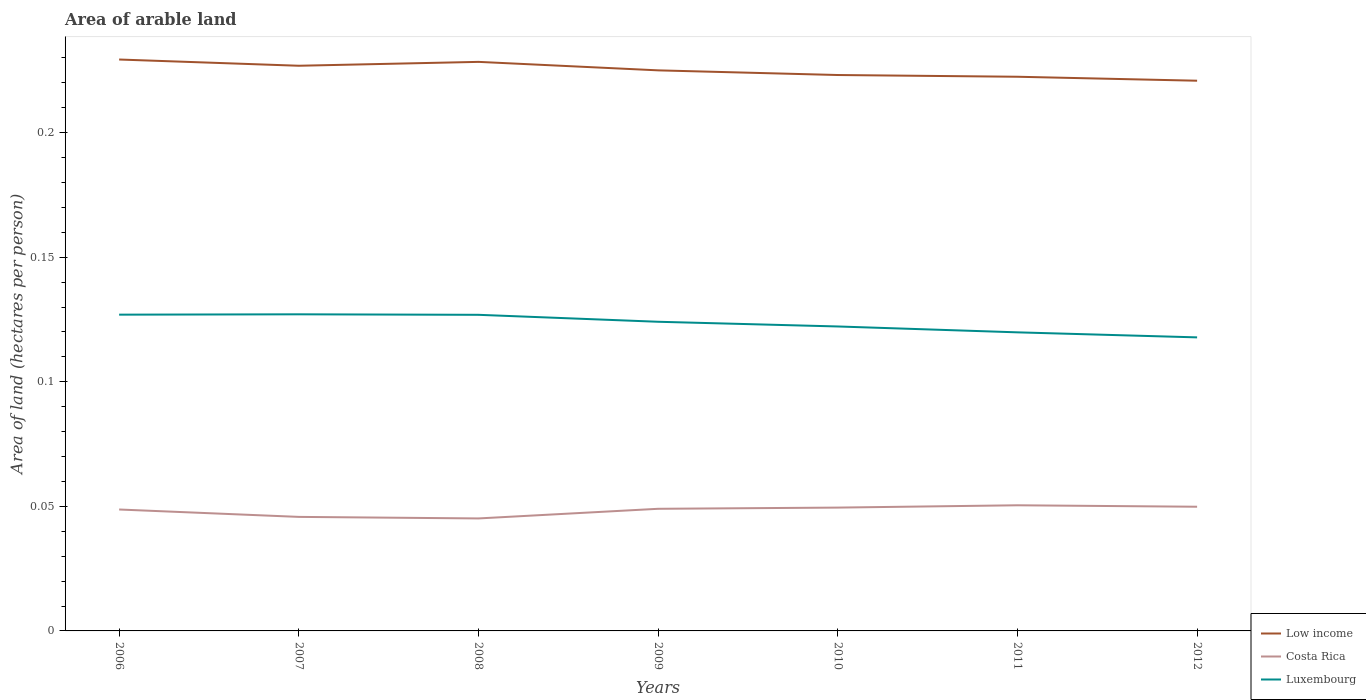Does the line corresponding to Costa Rica intersect with the line corresponding to Low income?
Ensure brevity in your answer.  No. Is the number of lines equal to the number of legend labels?
Keep it short and to the point. Yes. Across all years, what is the maximum total arable land in Luxembourg?
Give a very brief answer. 0.12. What is the total total arable land in Low income in the graph?
Offer a terse response. 0. What is the difference between the highest and the second highest total arable land in Costa Rica?
Your answer should be compact. 0.01. Is the total arable land in Low income strictly greater than the total arable land in Luxembourg over the years?
Your answer should be very brief. No. How many lines are there?
Provide a short and direct response. 3. What is the difference between two consecutive major ticks on the Y-axis?
Give a very brief answer. 0.05. Does the graph contain grids?
Give a very brief answer. No. What is the title of the graph?
Your response must be concise. Area of arable land. Does "Eritrea" appear as one of the legend labels in the graph?
Offer a very short reply. No. What is the label or title of the X-axis?
Keep it short and to the point. Years. What is the label or title of the Y-axis?
Make the answer very short. Area of land (hectares per person). What is the Area of land (hectares per person) of Low income in 2006?
Make the answer very short. 0.23. What is the Area of land (hectares per person) in Costa Rica in 2006?
Offer a very short reply. 0.05. What is the Area of land (hectares per person) in Luxembourg in 2006?
Provide a short and direct response. 0.13. What is the Area of land (hectares per person) in Low income in 2007?
Offer a very short reply. 0.23. What is the Area of land (hectares per person) of Costa Rica in 2007?
Offer a very short reply. 0.05. What is the Area of land (hectares per person) of Luxembourg in 2007?
Provide a succinct answer. 0.13. What is the Area of land (hectares per person) of Low income in 2008?
Give a very brief answer. 0.23. What is the Area of land (hectares per person) in Costa Rica in 2008?
Provide a succinct answer. 0.05. What is the Area of land (hectares per person) of Luxembourg in 2008?
Offer a very short reply. 0.13. What is the Area of land (hectares per person) in Low income in 2009?
Offer a very short reply. 0.23. What is the Area of land (hectares per person) in Costa Rica in 2009?
Provide a succinct answer. 0.05. What is the Area of land (hectares per person) of Luxembourg in 2009?
Give a very brief answer. 0.12. What is the Area of land (hectares per person) in Low income in 2010?
Provide a succinct answer. 0.22. What is the Area of land (hectares per person) of Costa Rica in 2010?
Your response must be concise. 0.05. What is the Area of land (hectares per person) of Luxembourg in 2010?
Provide a succinct answer. 0.12. What is the Area of land (hectares per person) in Low income in 2011?
Provide a succinct answer. 0.22. What is the Area of land (hectares per person) of Costa Rica in 2011?
Provide a short and direct response. 0.05. What is the Area of land (hectares per person) of Luxembourg in 2011?
Give a very brief answer. 0.12. What is the Area of land (hectares per person) in Low income in 2012?
Your response must be concise. 0.22. What is the Area of land (hectares per person) in Costa Rica in 2012?
Keep it short and to the point. 0.05. What is the Area of land (hectares per person) in Luxembourg in 2012?
Your response must be concise. 0.12. Across all years, what is the maximum Area of land (hectares per person) in Low income?
Offer a terse response. 0.23. Across all years, what is the maximum Area of land (hectares per person) of Costa Rica?
Your answer should be very brief. 0.05. Across all years, what is the maximum Area of land (hectares per person) of Luxembourg?
Offer a very short reply. 0.13. Across all years, what is the minimum Area of land (hectares per person) in Low income?
Ensure brevity in your answer.  0.22. Across all years, what is the minimum Area of land (hectares per person) of Costa Rica?
Give a very brief answer. 0.05. Across all years, what is the minimum Area of land (hectares per person) in Luxembourg?
Offer a terse response. 0.12. What is the total Area of land (hectares per person) in Low income in the graph?
Your response must be concise. 1.58. What is the total Area of land (hectares per person) in Costa Rica in the graph?
Your answer should be compact. 0.34. What is the total Area of land (hectares per person) in Luxembourg in the graph?
Make the answer very short. 0.86. What is the difference between the Area of land (hectares per person) in Low income in 2006 and that in 2007?
Your response must be concise. 0. What is the difference between the Area of land (hectares per person) of Costa Rica in 2006 and that in 2007?
Provide a succinct answer. 0. What is the difference between the Area of land (hectares per person) of Luxembourg in 2006 and that in 2007?
Offer a very short reply. -0. What is the difference between the Area of land (hectares per person) in Low income in 2006 and that in 2008?
Your response must be concise. 0. What is the difference between the Area of land (hectares per person) of Costa Rica in 2006 and that in 2008?
Ensure brevity in your answer.  0. What is the difference between the Area of land (hectares per person) in Luxembourg in 2006 and that in 2008?
Provide a short and direct response. 0. What is the difference between the Area of land (hectares per person) of Low income in 2006 and that in 2009?
Ensure brevity in your answer.  0. What is the difference between the Area of land (hectares per person) of Costa Rica in 2006 and that in 2009?
Keep it short and to the point. -0. What is the difference between the Area of land (hectares per person) in Luxembourg in 2006 and that in 2009?
Your answer should be compact. 0. What is the difference between the Area of land (hectares per person) in Low income in 2006 and that in 2010?
Give a very brief answer. 0.01. What is the difference between the Area of land (hectares per person) of Costa Rica in 2006 and that in 2010?
Offer a terse response. -0. What is the difference between the Area of land (hectares per person) of Luxembourg in 2006 and that in 2010?
Offer a terse response. 0. What is the difference between the Area of land (hectares per person) of Low income in 2006 and that in 2011?
Offer a terse response. 0.01. What is the difference between the Area of land (hectares per person) in Costa Rica in 2006 and that in 2011?
Ensure brevity in your answer.  -0. What is the difference between the Area of land (hectares per person) of Luxembourg in 2006 and that in 2011?
Ensure brevity in your answer.  0.01. What is the difference between the Area of land (hectares per person) in Low income in 2006 and that in 2012?
Offer a very short reply. 0.01. What is the difference between the Area of land (hectares per person) in Costa Rica in 2006 and that in 2012?
Offer a very short reply. -0. What is the difference between the Area of land (hectares per person) of Luxembourg in 2006 and that in 2012?
Your response must be concise. 0.01. What is the difference between the Area of land (hectares per person) of Low income in 2007 and that in 2008?
Make the answer very short. -0. What is the difference between the Area of land (hectares per person) of Costa Rica in 2007 and that in 2008?
Your answer should be very brief. 0. What is the difference between the Area of land (hectares per person) of Luxembourg in 2007 and that in 2008?
Your answer should be very brief. 0. What is the difference between the Area of land (hectares per person) in Low income in 2007 and that in 2009?
Provide a short and direct response. 0. What is the difference between the Area of land (hectares per person) in Costa Rica in 2007 and that in 2009?
Provide a short and direct response. -0. What is the difference between the Area of land (hectares per person) in Luxembourg in 2007 and that in 2009?
Give a very brief answer. 0. What is the difference between the Area of land (hectares per person) in Low income in 2007 and that in 2010?
Your response must be concise. 0. What is the difference between the Area of land (hectares per person) of Costa Rica in 2007 and that in 2010?
Ensure brevity in your answer.  -0. What is the difference between the Area of land (hectares per person) in Luxembourg in 2007 and that in 2010?
Offer a terse response. 0. What is the difference between the Area of land (hectares per person) of Low income in 2007 and that in 2011?
Make the answer very short. 0. What is the difference between the Area of land (hectares per person) in Costa Rica in 2007 and that in 2011?
Provide a succinct answer. -0. What is the difference between the Area of land (hectares per person) in Luxembourg in 2007 and that in 2011?
Ensure brevity in your answer.  0.01. What is the difference between the Area of land (hectares per person) of Low income in 2007 and that in 2012?
Offer a very short reply. 0.01. What is the difference between the Area of land (hectares per person) in Costa Rica in 2007 and that in 2012?
Ensure brevity in your answer.  -0. What is the difference between the Area of land (hectares per person) of Luxembourg in 2007 and that in 2012?
Provide a succinct answer. 0.01. What is the difference between the Area of land (hectares per person) in Low income in 2008 and that in 2009?
Give a very brief answer. 0. What is the difference between the Area of land (hectares per person) in Costa Rica in 2008 and that in 2009?
Keep it short and to the point. -0. What is the difference between the Area of land (hectares per person) of Luxembourg in 2008 and that in 2009?
Provide a succinct answer. 0. What is the difference between the Area of land (hectares per person) of Low income in 2008 and that in 2010?
Your answer should be compact. 0.01. What is the difference between the Area of land (hectares per person) of Costa Rica in 2008 and that in 2010?
Give a very brief answer. -0. What is the difference between the Area of land (hectares per person) in Luxembourg in 2008 and that in 2010?
Your answer should be very brief. 0. What is the difference between the Area of land (hectares per person) in Low income in 2008 and that in 2011?
Give a very brief answer. 0.01. What is the difference between the Area of land (hectares per person) of Costa Rica in 2008 and that in 2011?
Ensure brevity in your answer.  -0.01. What is the difference between the Area of land (hectares per person) of Luxembourg in 2008 and that in 2011?
Ensure brevity in your answer.  0.01. What is the difference between the Area of land (hectares per person) of Low income in 2008 and that in 2012?
Your answer should be compact. 0.01. What is the difference between the Area of land (hectares per person) in Costa Rica in 2008 and that in 2012?
Your answer should be very brief. -0. What is the difference between the Area of land (hectares per person) of Luxembourg in 2008 and that in 2012?
Offer a terse response. 0.01. What is the difference between the Area of land (hectares per person) of Low income in 2009 and that in 2010?
Ensure brevity in your answer.  0. What is the difference between the Area of land (hectares per person) of Costa Rica in 2009 and that in 2010?
Provide a short and direct response. -0. What is the difference between the Area of land (hectares per person) in Luxembourg in 2009 and that in 2010?
Your answer should be compact. 0. What is the difference between the Area of land (hectares per person) in Low income in 2009 and that in 2011?
Give a very brief answer. 0. What is the difference between the Area of land (hectares per person) in Costa Rica in 2009 and that in 2011?
Make the answer very short. -0. What is the difference between the Area of land (hectares per person) in Luxembourg in 2009 and that in 2011?
Provide a succinct answer. 0. What is the difference between the Area of land (hectares per person) in Low income in 2009 and that in 2012?
Ensure brevity in your answer.  0. What is the difference between the Area of land (hectares per person) of Costa Rica in 2009 and that in 2012?
Provide a succinct answer. -0. What is the difference between the Area of land (hectares per person) of Luxembourg in 2009 and that in 2012?
Provide a succinct answer. 0.01. What is the difference between the Area of land (hectares per person) of Low income in 2010 and that in 2011?
Give a very brief answer. 0. What is the difference between the Area of land (hectares per person) in Costa Rica in 2010 and that in 2011?
Provide a short and direct response. -0. What is the difference between the Area of land (hectares per person) in Luxembourg in 2010 and that in 2011?
Provide a succinct answer. 0. What is the difference between the Area of land (hectares per person) of Low income in 2010 and that in 2012?
Your response must be concise. 0. What is the difference between the Area of land (hectares per person) of Costa Rica in 2010 and that in 2012?
Offer a terse response. -0. What is the difference between the Area of land (hectares per person) of Luxembourg in 2010 and that in 2012?
Give a very brief answer. 0. What is the difference between the Area of land (hectares per person) of Low income in 2011 and that in 2012?
Offer a very short reply. 0. What is the difference between the Area of land (hectares per person) in Costa Rica in 2011 and that in 2012?
Provide a short and direct response. 0. What is the difference between the Area of land (hectares per person) of Luxembourg in 2011 and that in 2012?
Provide a succinct answer. 0. What is the difference between the Area of land (hectares per person) in Low income in 2006 and the Area of land (hectares per person) in Costa Rica in 2007?
Keep it short and to the point. 0.18. What is the difference between the Area of land (hectares per person) in Low income in 2006 and the Area of land (hectares per person) in Luxembourg in 2007?
Offer a very short reply. 0.1. What is the difference between the Area of land (hectares per person) in Costa Rica in 2006 and the Area of land (hectares per person) in Luxembourg in 2007?
Your answer should be very brief. -0.08. What is the difference between the Area of land (hectares per person) of Low income in 2006 and the Area of land (hectares per person) of Costa Rica in 2008?
Your response must be concise. 0.18. What is the difference between the Area of land (hectares per person) in Low income in 2006 and the Area of land (hectares per person) in Luxembourg in 2008?
Give a very brief answer. 0.1. What is the difference between the Area of land (hectares per person) of Costa Rica in 2006 and the Area of land (hectares per person) of Luxembourg in 2008?
Make the answer very short. -0.08. What is the difference between the Area of land (hectares per person) of Low income in 2006 and the Area of land (hectares per person) of Costa Rica in 2009?
Provide a succinct answer. 0.18. What is the difference between the Area of land (hectares per person) in Low income in 2006 and the Area of land (hectares per person) in Luxembourg in 2009?
Provide a succinct answer. 0.11. What is the difference between the Area of land (hectares per person) in Costa Rica in 2006 and the Area of land (hectares per person) in Luxembourg in 2009?
Your answer should be very brief. -0.08. What is the difference between the Area of land (hectares per person) in Low income in 2006 and the Area of land (hectares per person) in Costa Rica in 2010?
Give a very brief answer. 0.18. What is the difference between the Area of land (hectares per person) of Low income in 2006 and the Area of land (hectares per person) of Luxembourg in 2010?
Give a very brief answer. 0.11. What is the difference between the Area of land (hectares per person) in Costa Rica in 2006 and the Area of land (hectares per person) in Luxembourg in 2010?
Ensure brevity in your answer.  -0.07. What is the difference between the Area of land (hectares per person) of Low income in 2006 and the Area of land (hectares per person) of Costa Rica in 2011?
Keep it short and to the point. 0.18. What is the difference between the Area of land (hectares per person) in Low income in 2006 and the Area of land (hectares per person) in Luxembourg in 2011?
Your answer should be very brief. 0.11. What is the difference between the Area of land (hectares per person) of Costa Rica in 2006 and the Area of land (hectares per person) of Luxembourg in 2011?
Give a very brief answer. -0.07. What is the difference between the Area of land (hectares per person) of Low income in 2006 and the Area of land (hectares per person) of Costa Rica in 2012?
Your answer should be very brief. 0.18. What is the difference between the Area of land (hectares per person) in Low income in 2006 and the Area of land (hectares per person) in Luxembourg in 2012?
Offer a very short reply. 0.11. What is the difference between the Area of land (hectares per person) of Costa Rica in 2006 and the Area of land (hectares per person) of Luxembourg in 2012?
Provide a short and direct response. -0.07. What is the difference between the Area of land (hectares per person) in Low income in 2007 and the Area of land (hectares per person) in Costa Rica in 2008?
Your response must be concise. 0.18. What is the difference between the Area of land (hectares per person) of Costa Rica in 2007 and the Area of land (hectares per person) of Luxembourg in 2008?
Your response must be concise. -0.08. What is the difference between the Area of land (hectares per person) in Low income in 2007 and the Area of land (hectares per person) in Costa Rica in 2009?
Keep it short and to the point. 0.18. What is the difference between the Area of land (hectares per person) in Low income in 2007 and the Area of land (hectares per person) in Luxembourg in 2009?
Provide a succinct answer. 0.1. What is the difference between the Area of land (hectares per person) of Costa Rica in 2007 and the Area of land (hectares per person) of Luxembourg in 2009?
Ensure brevity in your answer.  -0.08. What is the difference between the Area of land (hectares per person) in Low income in 2007 and the Area of land (hectares per person) in Costa Rica in 2010?
Give a very brief answer. 0.18. What is the difference between the Area of land (hectares per person) of Low income in 2007 and the Area of land (hectares per person) of Luxembourg in 2010?
Ensure brevity in your answer.  0.1. What is the difference between the Area of land (hectares per person) of Costa Rica in 2007 and the Area of land (hectares per person) of Luxembourg in 2010?
Keep it short and to the point. -0.08. What is the difference between the Area of land (hectares per person) of Low income in 2007 and the Area of land (hectares per person) of Costa Rica in 2011?
Provide a short and direct response. 0.18. What is the difference between the Area of land (hectares per person) of Low income in 2007 and the Area of land (hectares per person) of Luxembourg in 2011?
Provide a short and direct response. 0.11. What is the difference between the Area of land (hectares per person) in Costa Rica in 2007 and the Area of land (hectares per person) in Luxembourg in 2011?
Ensure brevity in your answer.  -0.07. What is the difference between the Area of land (hectares per person) in Low income in 2007 and the Area of land (hectares per person) in Costa Rica in 2012?
Ensure brevity in your answer.  0.18. What is the difference between the Area of land (hectares per person) in Low income in 2007 and the Area of land (hectares per person) in Luxembourg in 2012?
Make the answer very short. 0.11. What is the difference between the Area of land (hectares per person) in Costa Rica in 2007 and the Area of land (hectares per person) in Luxembourg in 2012?
Give a very brief answer. -0.07. What is the difference between the Area of land (hectares per person) in Low income in 2008 and the Area of land (hectares per person) in Costa Rica in 2009?
Offer a terse response. 0.18. What is the difference between the Area of land (hectares per person) in Low income in 2008 and the Area of land (hectares per person) in Luxembourg in 2009?
Make the answer very short. 0.1. What is the difference between the Area of land (hectares per person) of Costa Rica in 2008 and the Area of land (hectares per person) of Luxembourg in 2009?
Provide a succinct answer. -0.08. What is the difference between the Area of land (hectares per person) of Low income in 2008 and the Area of land (hectares per person) of Costa Rica in 2010?
Ensure brevity in your answer.  0.18. What is the difference between the Area of land (hectares per person) of Low income in 2008 and the Area of land (hectares per person) of Luxembourg in 2010?
Your response must be concise. 0.11. What is the difference between the Area of land (hectares per person) of Costa Rica in 2008 and the Area of land (hectares per person) of Luxembourg in 2010?
Your response must be concise. -0.08. What is the difference between the Area of land (hectares per person) of Low income in 2008 and the Area of land (hectares per person) of Costa Rica in 2011?
Your answer should be very brief. 0.18. What is the difference between the Area of land (hectares per person) of Low income in 2008 and the Area of land (hectares per person) of Luxembourg in 2011?
Your response must be concise. 0.11. What is the difference between the Area of land (hectares per person) in Costa Rica in 2008 and the Area of land (hectares per person) in Luxembourg in 2011?
Your response must be concise. -0.07. What is the difference between the Area of land (hectares per person) of Low income in 2008 and the Area of land (hectares per person) of Costa Rica in 2012?
Your answer should be very brief. 0.18. What is the difference between the Area of land (hectares per person) in Low income in 2008 and the Area of land (hectares per person) in Luxembourg in 2012?
Make the answer very short. 0.11. What is the difference between the Area of land (hectares per person) of Costa Rica in 2008 and the Area of land (hectares per person) of Luxembourg in 2012?
Give a very brief answer. -0.07. What is the difference between the Area of land (hectares per person) of Low income in 2009 and the Area of land (hectares per person) of Costa Rica in 2010?
Keep it short and to the point. 0.18. What is the difference between the Area of land (hectares per person) of Low income in 2009 and the Area of land (hectares per person) of Luxembourg in 2010?
Your response must be concise. 0.1. What is the difference between the Area of land (hectares per person) of Costa Rica in 2009 and the Area of land (hectares per person) of Luxembourg in 2010?
Make the answer very short. -0.07. What is the difference between the Area of land (hectares per person) of Low income in 2009 and the Area of land (hectares per person) of Costa Rica in 2011?
Your answer should be very brief. 0.17. What is the difference between the Area of land (hectares per person) in Low income in 2009 and the Area of land (hectares per person) in Luxembourg in 2011?
Your response must be concise. 0.11. What is the difference between the Area of land (hectares per person) in Costa Rica in 2009 and the Area of land (hectares per person) in Luxembourg in 2011?
Provide a short and direct response. -0.07. What is the difference between the Area of land (hectares per person) of Low income in 2009 and the Area of land (hectares per person) of Costa Rica in 2012?
Make the answer very short. 0.18. What is the difference between the Area of land (hectares per person) of Low income in 2009 and the Area of land (hectares per person) of Luxembourg in 2012?
Provide a succinct answer. 0.11. What is the difference between the Area of land (hectares per person) in Costa Rica in 2009 and the Area of land (hectares per person) in Luxembourg in 2012?
Keep it short and to the point. -0.07. What is the difference between the Area of land (hectares per person) of Low income in 2010 and the Area of land (hectares per person) of Costa Rica in 2011?
Offer a terse response. 0.17. What is the difference between the Area of land (hectares per person) of Low income in 2010 and the Area of land (hectares per person) of Luxembourg in 2011?
Give a very brief answer. 0.1. What is the difference between the Area of land (hectares per person) in Costa Rica in 2010 and the Area of land (hectares per person) in Luxembourg in 2011?
Make the answer very short. -0.07. What is the difference between the Area of land (hectares per person) in Low income in 2010 and the Area of land (hectares per person) in Costa Rica in 2012?
Ensure brevity in your answer.  0.17. What is the difference between the Area of land (hectares per person) in Low income in 2010 and the Area of land (hectares per person) in Luxembourg in 2012?
Ensure brevity in your answer.  0.11. What is the difference between the Area of land (hectares per person) in Costa Rica in 2010 and the Area of land (hectares per person) in Luxembourg in 2012?
Give a very brief answer. -0.07. What is the difference between the Area of land (hectares per person) of Low income in 2011 and the Area of land (hectares per person) of Costa Rica in 2012?
Your answer should be very brief. 0.17. What is the difference between the Area of land (hectares per person) of Low income in 2011 and the Area of land (hectares per person) of Luxembourg in 2012?
Your response must be concise. 0.1. What is the difference between the Area of land (hectares per person) in Costa Rica in 2011 and the Area of land (hectares per person) in Luxembourg in 2012?
Your response must be concise. -0.07. What is the average Area of land (hectares per person) in Low income per year?
Offer a terse response. 0.23. What is the average Area of land (hectares per person) in Costa Rica per year?
Your answer should be compact. 0.05. What is the average Area of land (hectares per person) in Luxembourg per year?
Your response must be concise. 0.12. In the year 2006, what is the difference between the Area of land (hectares per person) of Low income and Area of land (hectares per person) of Costa Rica?
Ensure brevity in your answer.  0.18. In the year 2006, what is the difference between the Area of land (hectares per person) of Low income and Area of land (hectares per person) of Luxembourg?
Make the answer very short. 0.1. In the year 2006, what is the difference between the Area of land (hectares per person) of Costa Rica and Area of land (hectares per person) of Luxembourg?
Provide a short and direct response. -0.08. In the year 2007, what is the difference between the Area of land (hectares per person) in Low income and Area of land (hectares per person) in Costa Rica?
Make the answer very short. 0.18. In the year 2007, what is the difference between the Area of land (hectares per person) of Low income and Area of land (hectares per person) of Luxembourg?
Your answer should be very brief. 0.1. In the year 2007, what is the difference between the Area of land (hectares per person) in Costa Rica and Area of land (hectares per person) in Luxembourg?
Give a very brief answer. -0.08. In the year 2008, what is the difference between the Area of land (hectares per person) of Low income and Area of land (hectares per person) of Costa Rica?
Your answer should be compact. 0.18. In the year 2008, what is the difference between the Area of land (hectares per person) in Low income and Area of land (hectares per person) in Luxembourg?
Your response must be concise. 0.1. In the year 2008, what is the difference between the Area of land (hectares per person) in Costa Rica and Area of land (hectares per person) in Luxembourg?
Give a very brief answer. -0.08. In the year 2009, what is the difference between the Area of land (hectares per person) in Low income and Area of land (hectares per person) in Costa Rica?
Offer a very short reply. 0.18. In the year 2009, what is the difference between the Area of land (hectares per person) of Low income and Area of land (hectares per person) of Luxembourg?
Offer a terse response. 0.1. In the year 2009, what is the difference between the Area of land (hectares per person) in Costa Rica and Area of land (hectares per person) in Luxembourg?
Keep it short and to the point. -0.08. In the year 2010, what is the difference between the Area of land (hectares per person) of Low income and Area of land (hectares per person) of Costa Rica?
Your response must be concise. 0.17. In the year 2010, what is the difference between the Area of land (hectares per person) of Low income and Area of land (hectares per person) of Luxembourg?
Provide a short and direct response. 0.1. In the year 2010, what is the difference between the Area of land (hectares per person) of Costa Rica and Area of land (hectares per person) of Luxembourg?
Keep it short and to the point. -0.07. In the year 2011, what is the difference between the Area of land (hectares per person) in Low income and Area of land (hectares per person) in Costa Rica?
Provide a succinct answer. 0.17. In the year 2011, what is the difference between the Area of land (hectares per person) of Low income and Area of land (hectares per person) of Luxembourg?
Your answer should be very brief. 0.1. In the year 2011, what is the difference between the Area of land (hectares per person) of Costa Rica and Area of land (hectares per person) of Luxembourg?
Ensure brevity in your answer.  -0.07. In the year 2012, what is the difference between the Area of land (hectares per person) of Low income and Area of land (hectares per person) of Costa Rica?
Offer a terse response. 0.17. In the year 2012, what is the difference between the Area of land (hectares per person) in Low income and Area of land (hectares per person) in Luxembourg?
Ensure brevity in your answer.  0.1. In the year 2012, what is the difference between the Area of land (hectares per person) of Costa Rica and Area of land (hectares per person) of Luxembourg?
Give a very brief answer. -0.07. What is the ratio of the Area of land (hectares per person) of Costa Rica in 2006 to that in 2007?
Keep it short and to the point. 1.06. What is the ratio of the Area of land (hectares per person) in Luxembourg in 2006 to that in 2007?
Make the answer very short. 1. What is the ratio of the Area of land (hectares per person) of Costa Rica in 2006 to that in 2008?
Offer a terse response. 1.08. What is the ratio of the Area of land (hectares per person) in Low income in 2006 to that in 2009?
Make the answer very short. 1.02. What is the ratio of the Area of land (hectares per person) of Costa Rica in 2006 to that in 2009?
Your response must be concise. 0.99. What is the ratio of the Area of land (hectares per person) of Low income in 2006 to that in 2010?
Make the answer very short. 1.03. What is the ratio of the Area of land (hectares per person) in Costa Rica in 2006 to that in 2010?
Offer a terse response. 0.98. What is the ratio of the Area of land (hectares per person) in Luxembourg in 2006 to that in 2010?
Provide a short and direct response. 1.04. What is the ratio of the Area of land (hectares per person) in Low income in 2006 to that in 2011?
Make the answer very short. 1.03. What is the ratio of the Area of land (hectares per person) of Costa Rica in 2006 to that in 2011?
Provide a short and direct response. 0.97. What is the ratio of the Area of land (hectares per person) in Luxembourg in 2006 to that in 2011?
Your answer should be very brief. 1.06. What is the ratio of the Area of land (hectares per person) of Low income in 2006 to that in 2012?
Make the answer very short. 1.04. What is the ratio of the Area of land (hectares per person) in Costa Rica in 2006 to that in 2012?
Provide a short and direct response. 0.98. What is the ratio of the Area of land (hectares per person) in Luxembourg in 2006 to that in 2012?
Offer a terse response. 1.08. What is the ratio of the Area of land (hectares per person) in Costa Rica in 2007 to that in 2008?
Your answer should be compact. 1.01. What is the ratio of the Area of land (hectares per person) in Low income in 2007 to that in 2009?
Your answer should be compact. 1.01. What is the ratio of the Area of land (hectares per person) of Costa Rica in 2007 to that in 2009?
Keep it short and to the point. 0.93. What is the ratio of the Area of land (hectares per person) in Luxembourg in 2007 to that in 2009?
Make the answer very short. 1.02. What is the ratio of the Area of land (hectares per person) in Low income in 2007 to that in 2010?
Your answer should be compact. 1.02. What is the ratio of the Area of land (hectares per person) of Costa Rica in 2007 to that in 2010?
Offer a terse response. 0.92. What is the ratio of the Area of land (hectares per person) of Luxembourg in 2007 to that in 2010?
Provide a short and direct response. 1.04. What is the ratio of the Area of land (hectares per person) of Low income in 2007 to that in 2011?
Provide a short and direct response. 1.02. What is the ratio of the Area of land (hectares per person) of Costa Rica in 2007 to that in 2011?
Your answer should be compact. 0.91. What is the ratio of the Area of land (hectares per person) in Luxembourg in 2007 to that in 2011?
Provide a short and direct response. 1.06. What is the ratio of the Area of land (hectares per person) of Low income in 2007 to that in 2012?
Your answer should be compact. 1.03. What is the ratio of the Area of land (hectares per person) in Costa Rica in 2007 to that in 2012?
Keep it short and to the point. 0.92. What is the ratio of the Area of land (hectares per person) in Luxembourg in 2007 to that in 2012?
Give a very brief answer. 1.08. What is the ratio of the Area of land (hectares per person) in Low income in 2008 to that in 2009?
Offer a terse response. 1.02. What is the ratio of the Area of land (hectares per person) of Costa Rica in 2008 to that in 2009?
Keep it short and to the point. 0.92. What is the ratio of the Area of land (hectares per person) in Luxembourg in 2008 to that in 2009?
Ensure brevity in your answer.  1.02. What is the ratio of the Area of land (hectares per person) of Low income in 2008 to that in 2010?
Give a very brief answer. 1.02. What is the ratio of the Area of land (hectares per person) in Costa Rica in 2008 to that in 2010?
Ensure brevity in your answer.  0.91. What is the ratio of the Area of land (hectares per person) in Luxembourg in 2008 to that in 2010?
Provide a succinct answer. 1.04. What is the ratio of the Area of land (hectares per person) in Low income in 2008 to that in 2011?
Offer a terse response. 1.03. What is the ratio of the Area of land (hectares per person) in Costa Rica in 2008 to that in 2011?
Offer a very short reply. 0.9. What is the ratio of the Area of land (hectares per person) of Luxembourg in 2008 to that in 2011?
Ensure brevity in your answer.  1.06. What is the ratio of the Area of land (hectares per person) in Low income in 2008 to that in 2012?
Your response must be concise. 1.03. What is the ratio of the Area of land (hectares per person) in Costa Rica in 2008 to that in 2012?
Ensure brevity in your answer.  0.91. What is the ratio of the Area of land (hectares per person) in Luxembourg in 2008 to that in 2012?
Provide a succinct answer. 1.08. What is the ratio of the Area of land (hectares per person) in Low income in 2009 to that in 2010?
Your response must be concise. 1.01. What is the ratio of the Area of land (hectares per person) in Costa Rica in 2009 to that in 2010?
Your answer should be compact. 0.99. What is the ratio of the Area of land (hectares per person) of Luxembourg in 2009 to that in 2010?
Make the answer very short. 1.02. What is the ratio of the Area of land (hectares per person) of Low income in 2009 to that in 2011?
Offer a terse response. 1.01. What is the ratio of the Area of land (hectares per person) in Costa Rica in 2009 to that in 2011?
Your response must be concise. 0.97. What is the ratio of the Area of land (hectares per person) of Luxembourg in 2009 to that in 2011?
Offer a very short reply. 1.04. What is the ratio of the Area of land (hectares per person) in Low income in 2009 to that in 2012?
Provide a succinct answer. 1.02. What is the ratio of the Area of land (hectares per person) in Costa Rica in 2009 to that in 2012?
Provide a succinct answer. 0.98. What is the ratio of the Area of land (hectares per person) of Luxembourg in 2009 to that in 2012?
Make the answer very short. 1.05. What is the ratio of the Area of land (hectares per person) in Costa Rica in 2010 to that in 2011?
Provide a short and direct response. 0.98. What is the ratio of the Area of land (hectares per person) of Luxembourg in 2010 to that in 2011?
Give a very brief answer. 1.02. What is the ratio of the Area of land (hectares per person) of Low income in 2010 to that in 2012?
Offer a very short reply. 1.01. What is the ratio of the Area of land (hectares per person) in Costa Rica in 2010 to that in 2012?
Your answer should be very brief. 0.99. What is the ratio of the Area of land (hectares per person) of Luxembourg in 2010 to that in 2012?
Make the answer very short. 1.04. What is the ratio of the Area of land (hectares per person) in Low income in 2011 to that in 2012?
Your response must be concise. 1.01. What is the ratio of the Area of land (hectares per person) in Costa Rica in 2011 to that in 2012?
Your response must be concise. 1.01. What is the ratio of the Area of land (hectares per person) in Luxembourg in 2011 to that in 2012?
Provide a short and direct response. 1.02. What is the difference between the highest and the second highest Area of land (hectares per person) in Low income?
Keep it short and to the point. 0. What is the difference between the highest and the second highest Area of land (hectares per person) of Costa Rica?
Your answer should be very brief. 0. What is the difference between the highest and the second highest Area of land (hectares per person) of Luxembourg?
Offer a very short reply. 0. What is the difference between the highest and the lowest Area of land (hectares per person) of Low income?
Offer a very short reply. 0.01. What is the difference between the highest and the lowest Area of land (hectares per person) of Costa Rica?
Provide a succinct answer. 0.01. What is the difference between the highest and the lowest Area of land (hectares per person) in Luxembourg?
Make the answer very short. 0.01. 